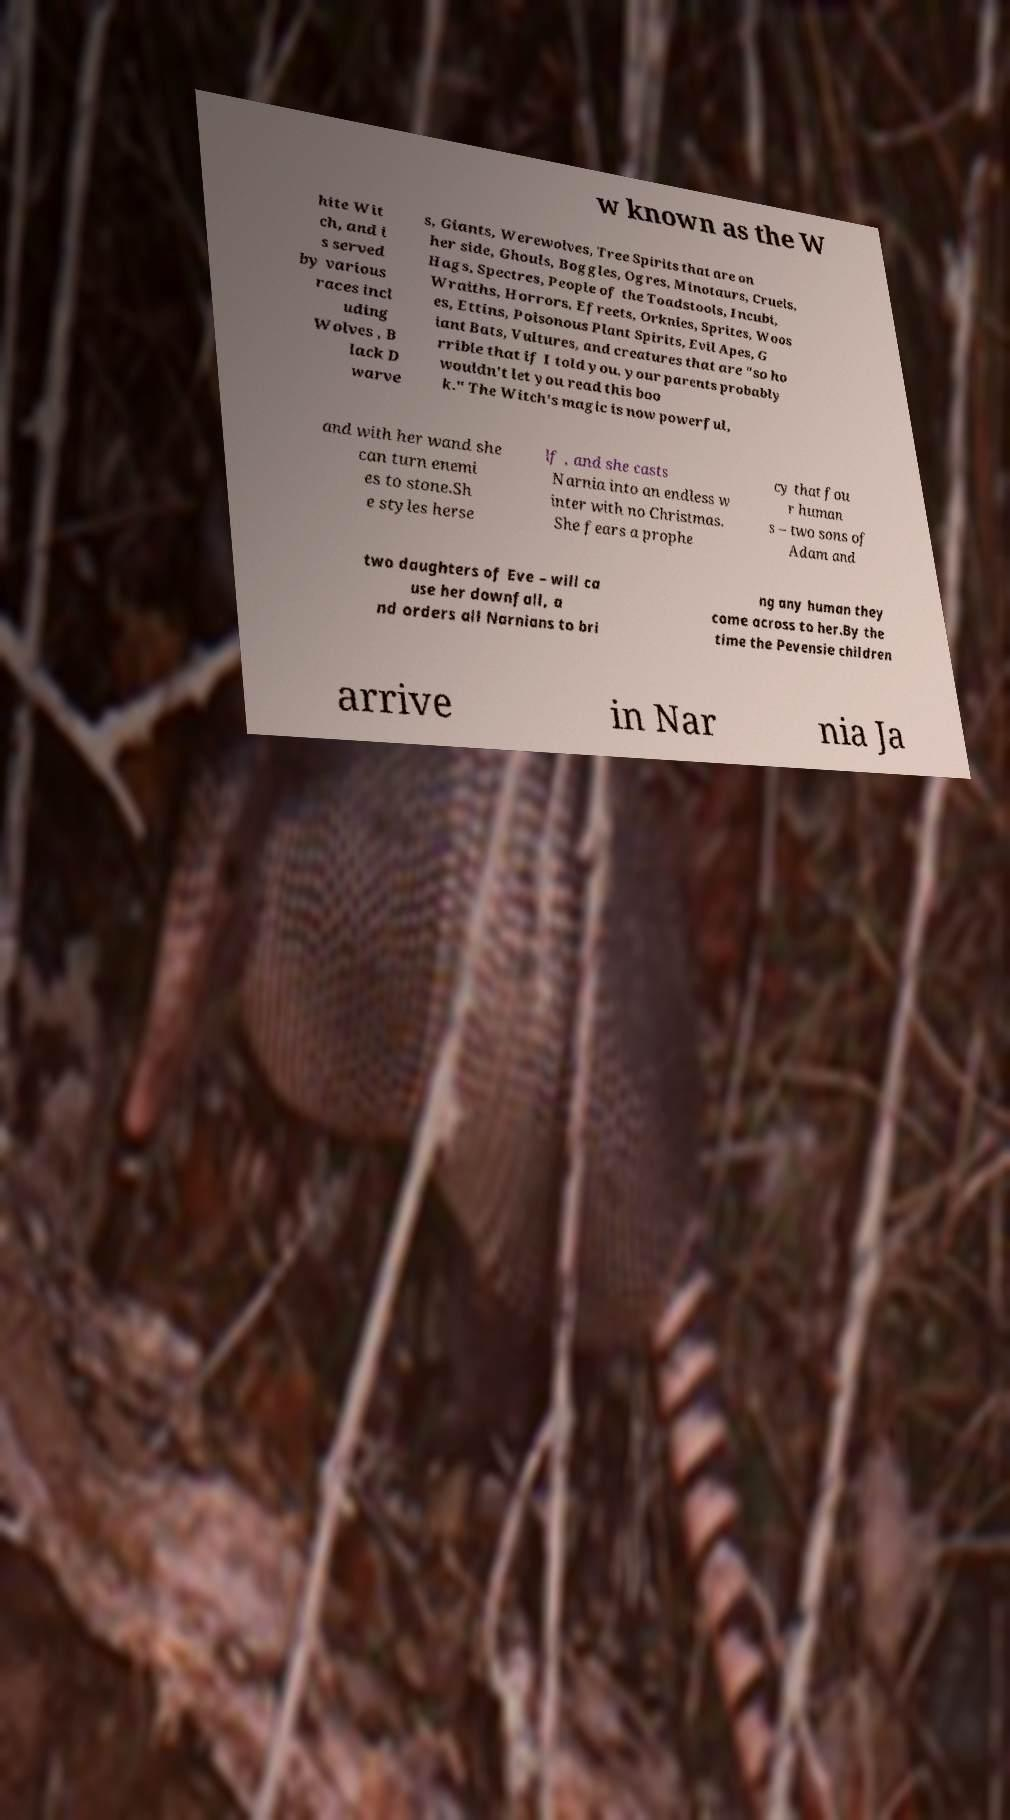Can you accurately transcribe the text from the provided image for me? w known as the W hite Wit ch, and i s served by various races incl uding Wolves , B lack D warve s, Giants, Werewolves, Tree Spirits that are on her side, Ghouls, Boggles, Ogres, Minotaurs, Cruels, Hags, Spectres, People of the Toadstools, Incubi, Wraiths, Horrors, Efreets, Orknies, Sprites, Woos es, Ettins, Poisonous Plant Spirits, Evil Apes, G iant Bats, Vultures, and creatures that are "so ho rrible that if I told you, your parents probably wouldn't let you read this boo k." The Witch's magic is now powerful, and with her wand she can turn enemi es to stone.Sh e styles herse lf , and she casts Narnia into an endless w inter with no Christmas. She fears a prophe cy that fou r human s – two sons of Adam and two daughters of Eve – will ca use her downfall, a nd orders all Narnians to bri ng any human they come across to her.By the time the Pevensie children arrive in Nar nia Ja 